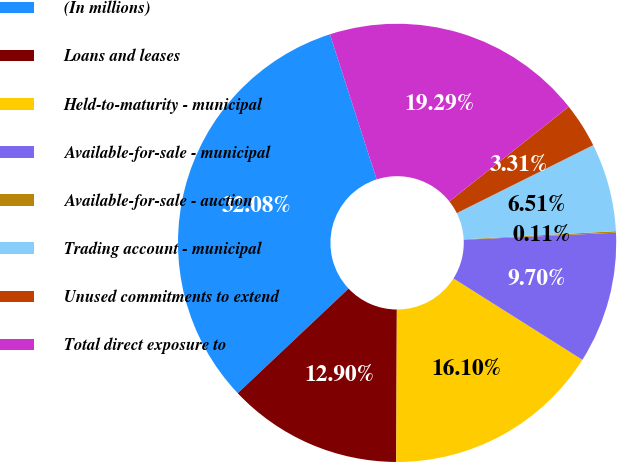<chart> <loc_0><loc_0><loc_500><loc_500><pie_chart><fcel>(In millions)<fcel>Loans and leases<fcel>Held-to-maturity - municipal<fcel>Available-for-sale - municipal<fcel>Available-for-sale - auction<fcel>Trading account - municipal<fcel>Unused commitments to extend<fcel>Total direct exposure to<nl><fcel>32.08%<fcel>12.9%<fcel>16.1%<fcel>9.7%<fcel>0.11%<fcel>6.51%<fcel>3.31%<fcel>19.29%<nl></chart> 